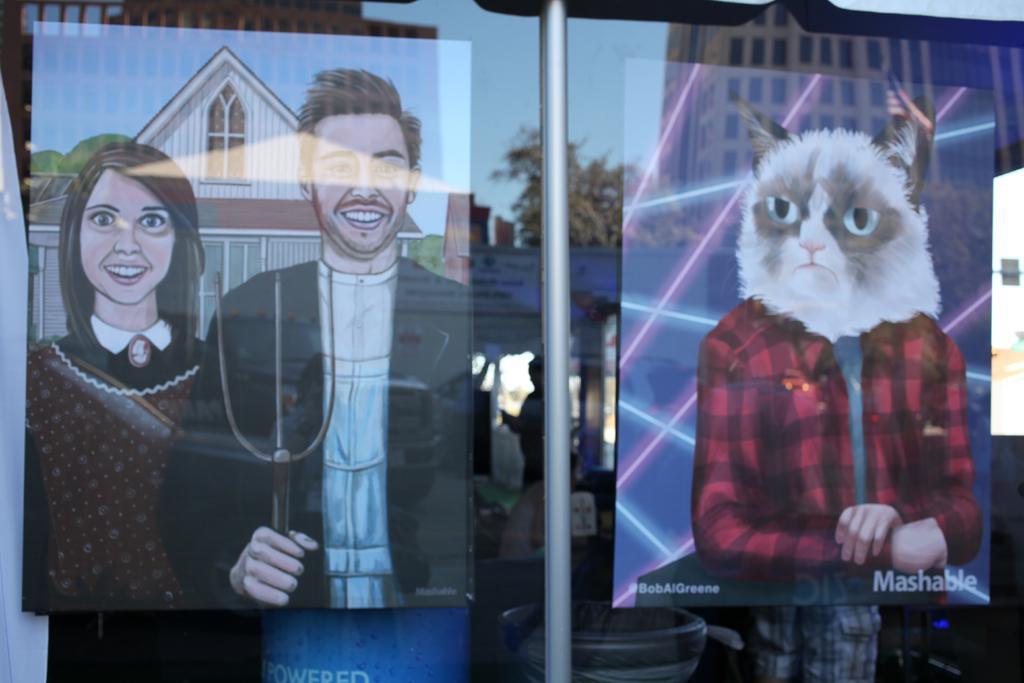In one or two sentences, can you explain what this image depicts? In this picture we can see a glass window. Behind the glass window, there are two paintings, two persons and some objects. On the glass window, we can see the reflections of buildings, a tree and the sky. 